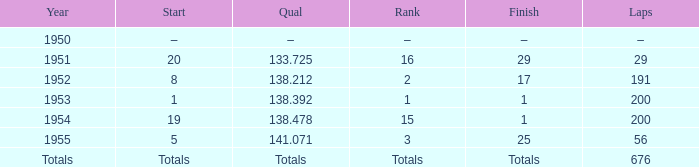What standing that commenced at 19? 15.0. 